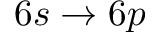<formula> <loc_0><loc_0><loc_500><loc_500>6 s \rightarrow 6 p</formula> 